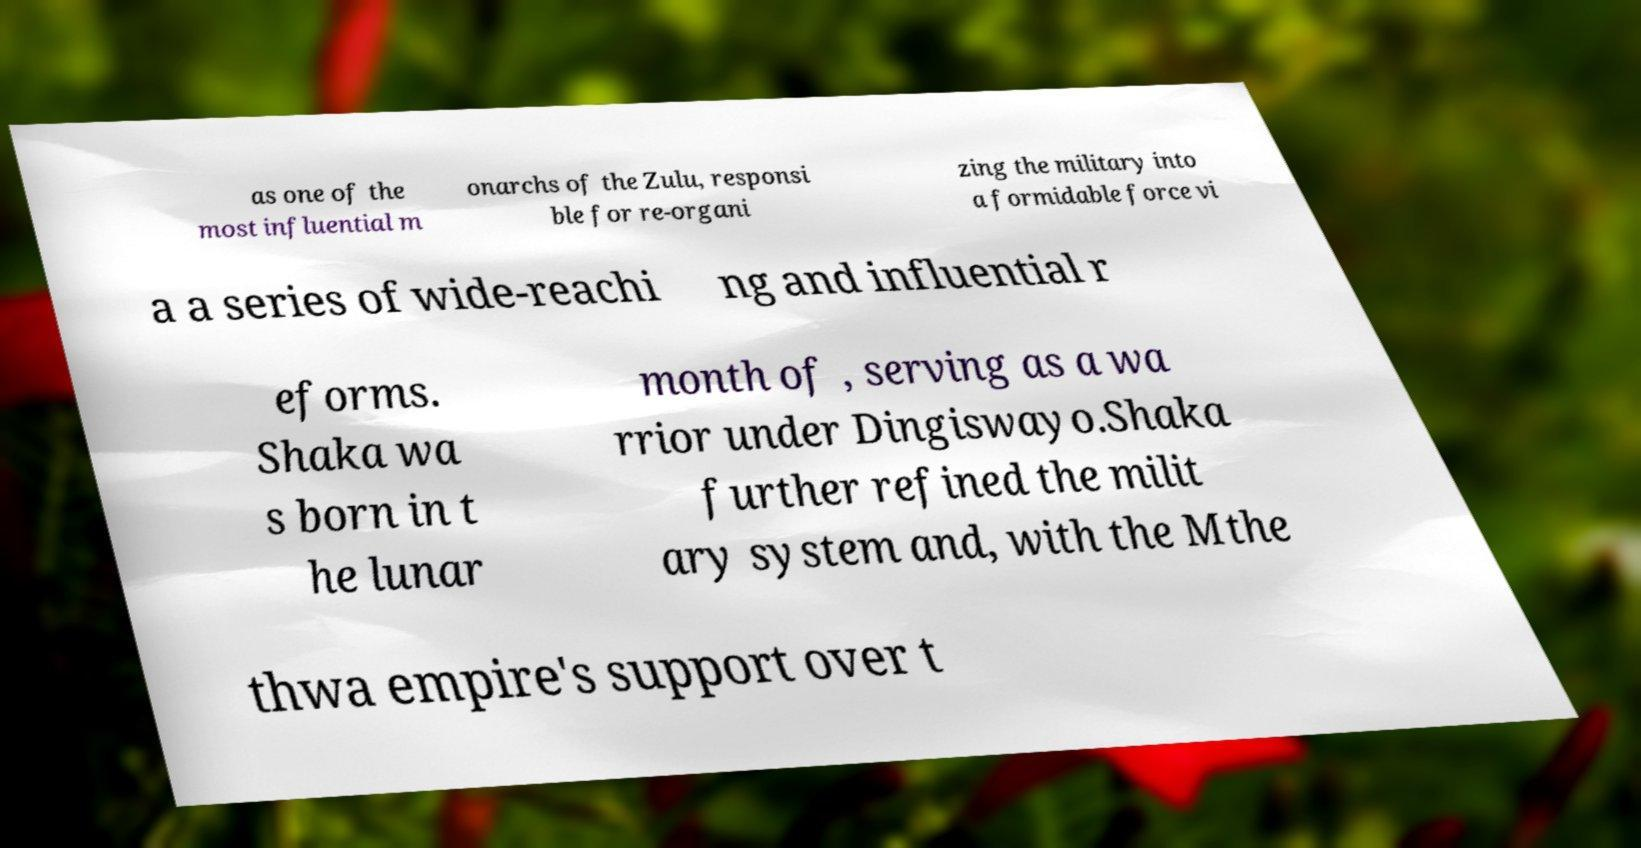Can you accurately transcribe the text from the provided image for me? as one of the most influential m onarchs of the Zulu, responsi ble for re-organi zing the military into a formidable force vi a a series of wide-reachi ng and influential r eforms. Shaka wa s born in t he lunar month of , serving as a wa rrior under Dingiswayo.Shaka further refined the milit ary system and, with the Mthe thwa empire's support over t 